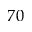<formula> <loc_0><loc_0><loc_500><loc_500>7 0</formula> 